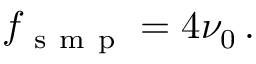Convert formula to latex. <formula><loc_0><loc_0><loc_500><loc_500>f _ { s m p } = 4 \nu _ { 0 } \, .</formula> 